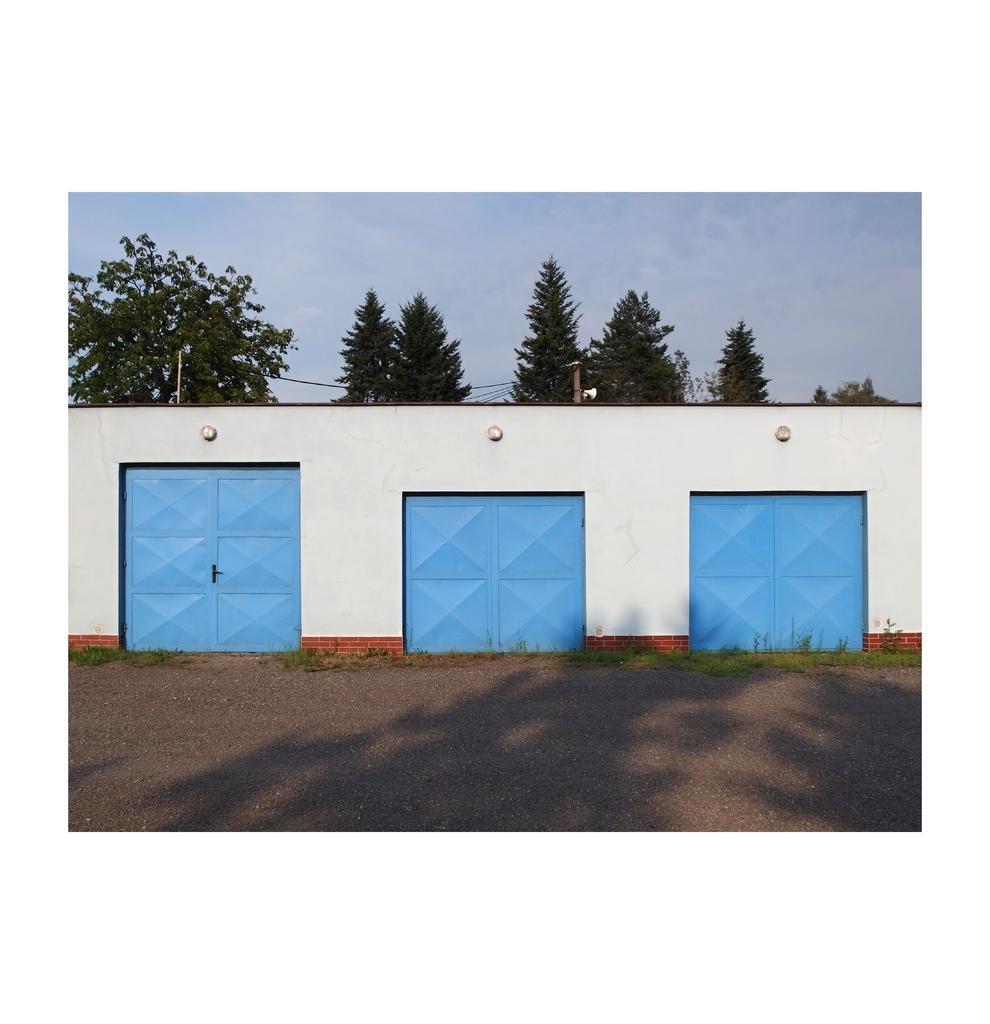Can you describe this image briefly? This image consists of three doors in blue color. It looks like a shed. And we can see three lamps. In the background, there are trees. At the top, there is sky. At the bottom, there is a road. 